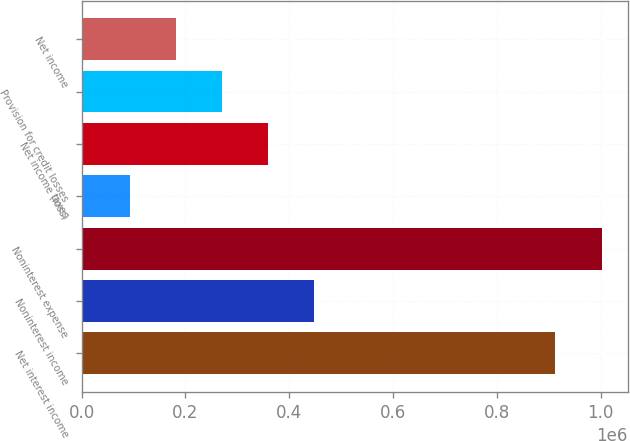<chart> <loc_0><loc_0><loc_500><loc_500><bar_chart><fcel>Net interest income<fcel>Noninterest income<fcel>Noninterest expense<fcel>taxes<fcel>Net income (loss)<fcel>Provision for credit losses<fcel>Net income<nl><fcel>912992<fcel>448548<fcel>1.00195e+06<fcel>92722<fcel>359592<fcel>270635<fcel>181679<nl></chart> 